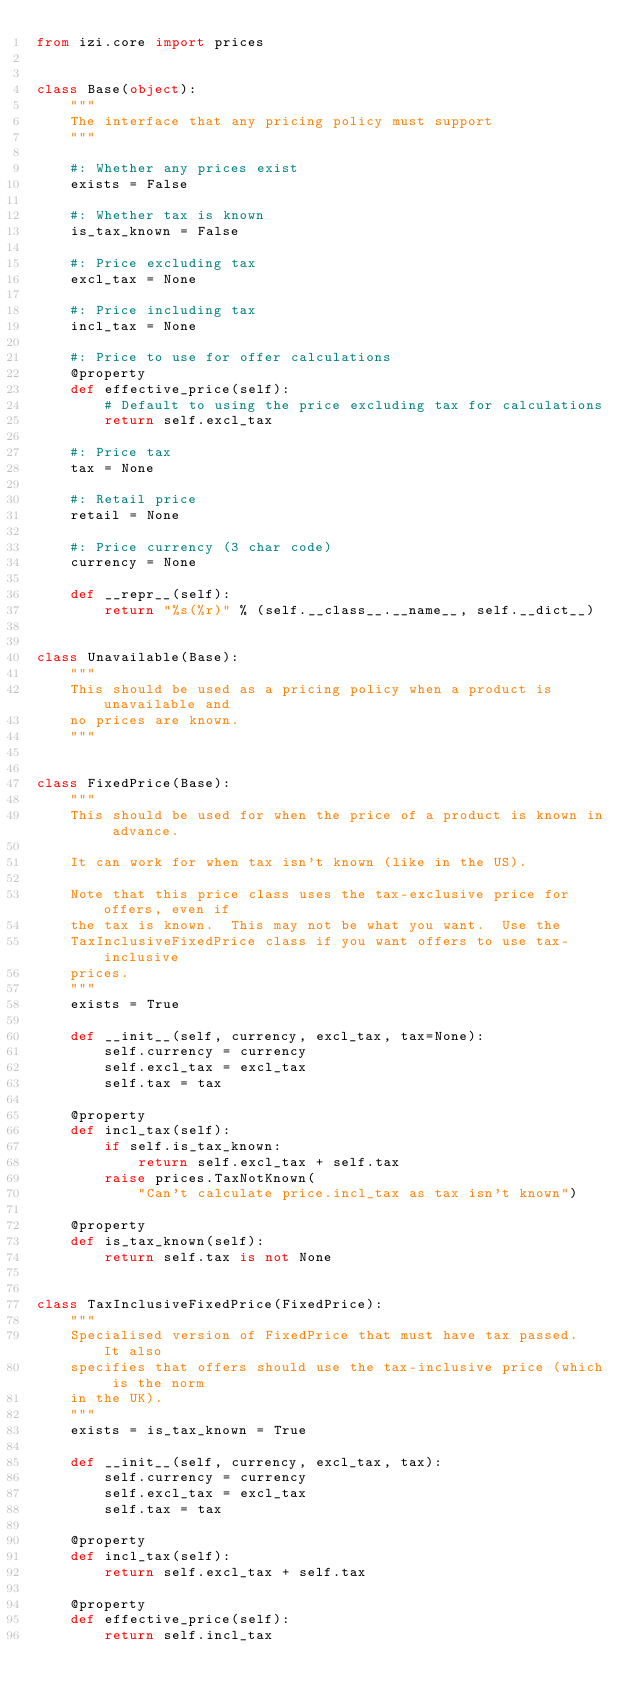Convert code to text. <code><loc_0><loc_0><loc_500><loc_500><_Python_>from izi.core import prices


class Base(object):
    """
    The interface that any pricing policy must support
    """

    #: Whether any prices exist
    exists = False

    #: Whether tax is known
    is_tax_known = False

    #: Price excluding tax
    excl_tax = None

    #: Price including tax
    incl_tax = None

    #: Price to use for offer calculations
    @property
    def effective_price(self):
        # Default to using the price excluding tax for calculations
        return self.excl_tax

    #: Price tax
    tax = None

    #: Retail price
    retail = None

    #: Price currency (3 char code)
    currency = None

    def __repr__(self):
        return "%s(%r)" % (self.__class__.__name__, self.__dict__)


class Unavailable(Base):
    """
    This should be used as a pricing policy when a product is unavailable and
    no prices are known.
    """


class FixedPrice(Base):
    """
    This should be used for when the price of a product is known in advance.

    It can work for when tax isn't known (like in the US).

    Note that this price class uses the tax-exclusive price for offers, even if
    the tax is known.  This may not be what you want.  Use the
    TaxInclusiveFixedPrice class if you want offers to use tax-inclusive
    prices.
    """
    exists = True

    def __init__(self, currency, excl_tax, tax=None):
        self.currency = currency
        self.excl_tax = excl_tax
        self.tax = tax

    @property
    def incl_tax(self):
        if self.is_tax_known:
            return self.excl_tax + self.tax
        raise prices.TaxNotKnown(
            "Can't calculate price.incl_tax as tax isn't known")

    @property
    def is_tax_known(self):
        return self.tax is not None


class TaxInclusiveFixedPrice(FixedPrice):
    """
    Specialised version of FixedPrice that must have tax passed.  It also
    specifies that offers should use the tax-inclusive price (which is the norm
    in the UK).
    """
    exists = is_tax_known = True

    def __init__(self, currency, excl_tax, tax):
        self.currency = currency
        self.excl_tax = excl_tax
        self.tax = tax

    @property
    def incl_tax(self):
        return self.excl_tax + self.tax

    @property
    def effective_price(self):
        return self.incl_tax
</code> 